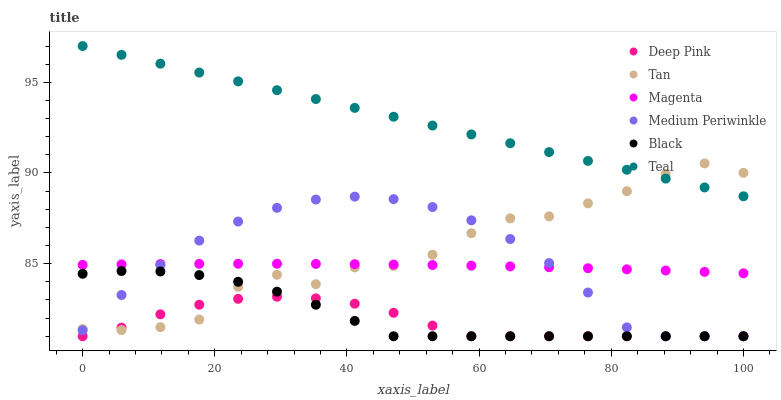Does Deep Pink have the minimum area under the curve?
Answer yes or no. Yes. Does Teal have the maximum area under the curve?
Answer yes or no. Yes. Does Medium Periwinkle have the minimum area under the curve?
Answer yes or no. No. Does Medium Periwinkle have the maximum area under the curve?
Answer yes or no. No. Is Teal the smoothest?
Answer yes or no. Yes. Is Tan the roughest?
Answer yes or no. Yes. Is Medium Periwinkle the smoothest?
Answer yes or no. No. Is Medium Periwinkle the roughest?
Answer yes or no. No. Does Deep Pink have the lowest value?
Answer yes or no. Yes. Does Teal have the lowest value?
Answer yes or no. No. Does Teal have the highest value?
Answer yes or no. Yes. Does Medium Periwinkle have the highest value?
Answer yes or no. No. Is Magenta less than Teal?
Answer yes or no. Yes. Is Magenta greater than Black?
Answer yes or no. Yes. Does Deep Pink intersect Black?
Answer yes or no. Yes. Is Deep Pink less than Black?
Answer yes or no. No. Is Deep Pink greater than Black?
Answer yes or no. No. Does Magenta intersect Teal?
Answer yes or no. No. 